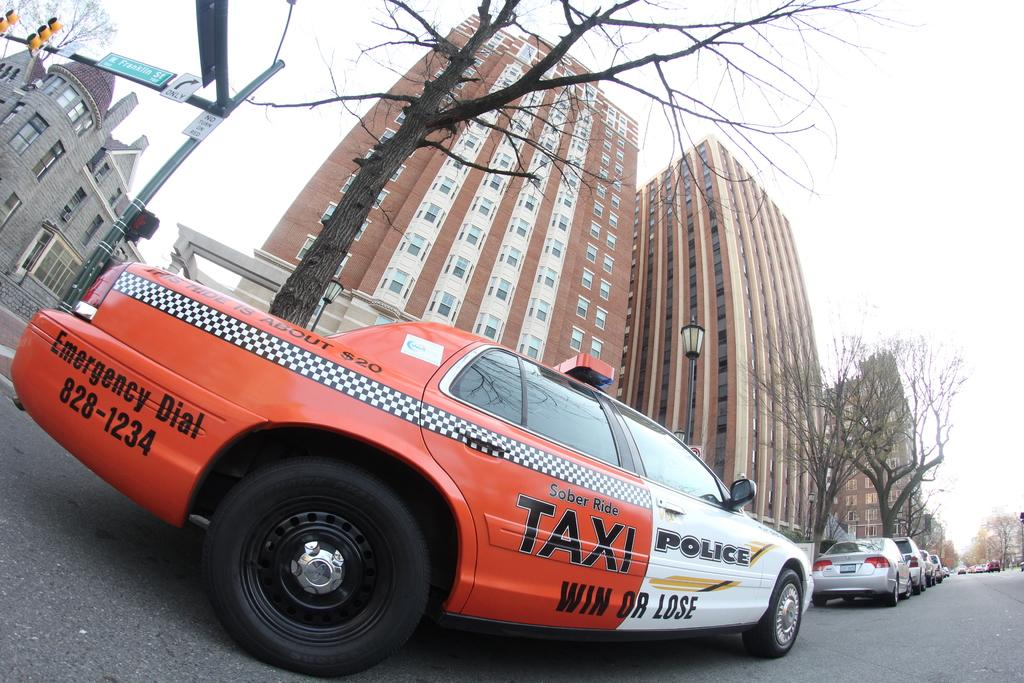<image>
Offer a succinct explanation of the picture presented. A taxi cab that is half Taxi and half Police that says WIN OR LOSE. 